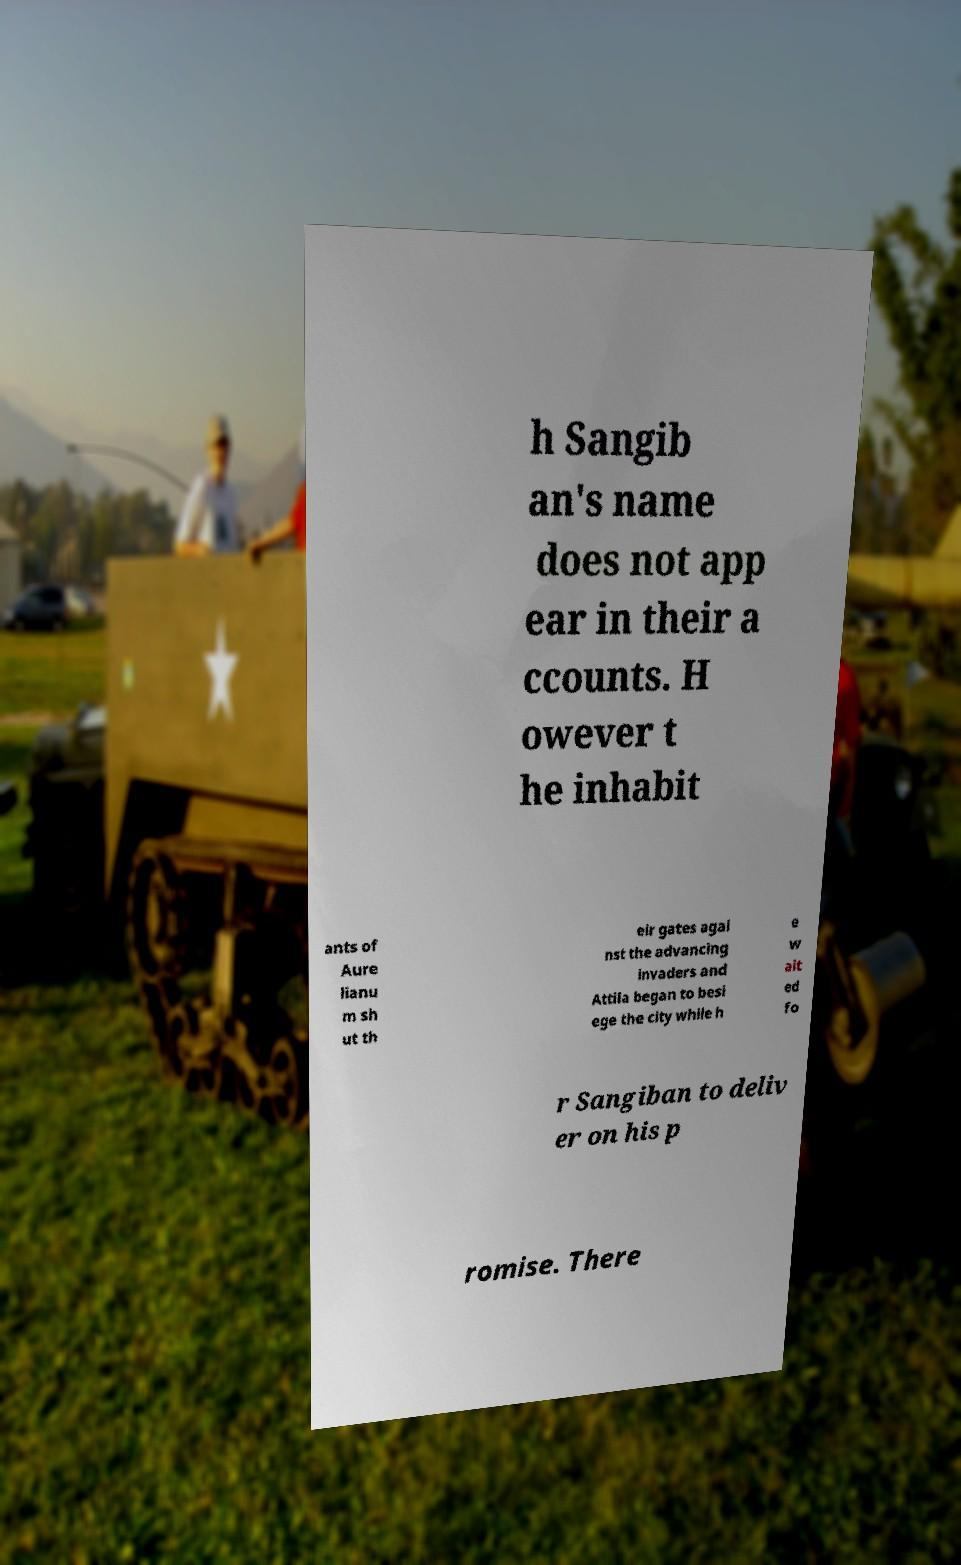For documentation purposes, I need the text within this image transcribed. Could you provide that? h Sangib an's name does not app ear in their a ccounts. H owever t he inhabit ants of Aure lianu m sh ut th eir gates agai nst the advancing invaders and Attila began to besi ege the city while h e w ait ed fo r Sangiban to deliv er on his p romise. There 